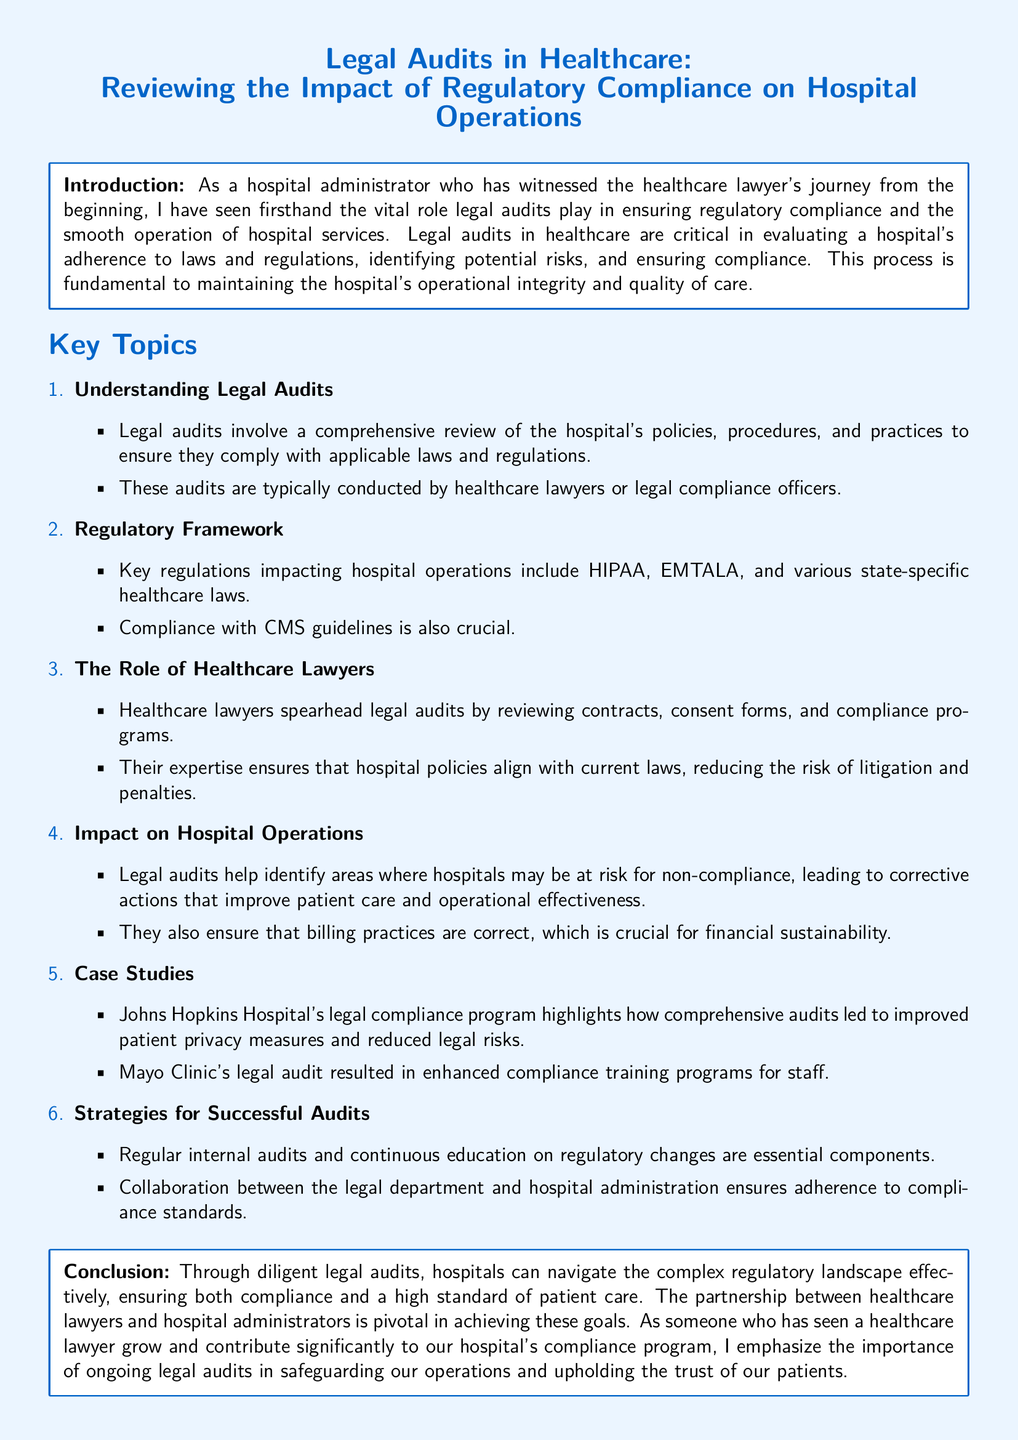what is the title of the document? The title is presented prominently at the top of the document.
Answer: Legal Audits in Healthcare: Reviewing the Impact of Regulatory Compliance on Hospital Operations who typically conducts legal audits? The document states the role of healthcare lawyers or legal compliance officers in conducting these audits.
Answer: healthcare lawyers or legal compliance officers what is one of the key regulations impacting hospital operations? The document lists several important regulations, and HIPAA is mentioned as a key one.
Answer: HIPAA which hospital's legal compliance program is highlighted as a case study? The document specifically mentions a notable case study focused on Johns Hopkins Hospital.
Answer: Johns Hopkins Hospital what are essential components for successful audits according to the document? The document describes regular internal audits and continuous education on regulatory changes as essential components.
Answer: regular internal audits and continuous education what is the main impact of legal audits on hospital operations? The impact is discussed, including identifying non-compliance risks and improving patient care.
Answer: improving patient care who is emphasized as pivotal in achieving compliance goals? The document stresses the partnership between hospital administrators and healthcare lawyers.
Answer: healthcare lawyers and hospital administrators what type of training program was enhanced at Mayo Clinic due to legal audits? The document states that enhanced compliance training programs for staff were a result of the legal audit at Mayo Clinic.
Answer: compliance training programs for staff 